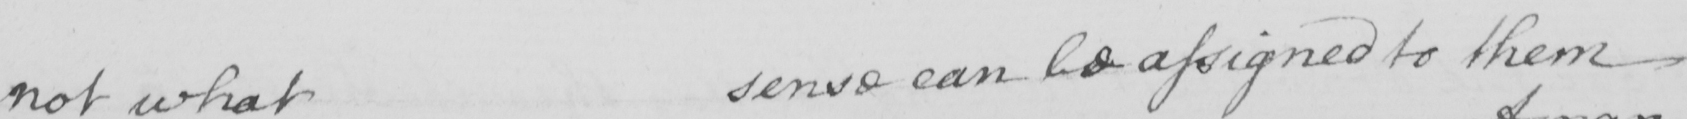What text is written in this handwritten line? not what sense can be assigned to them 